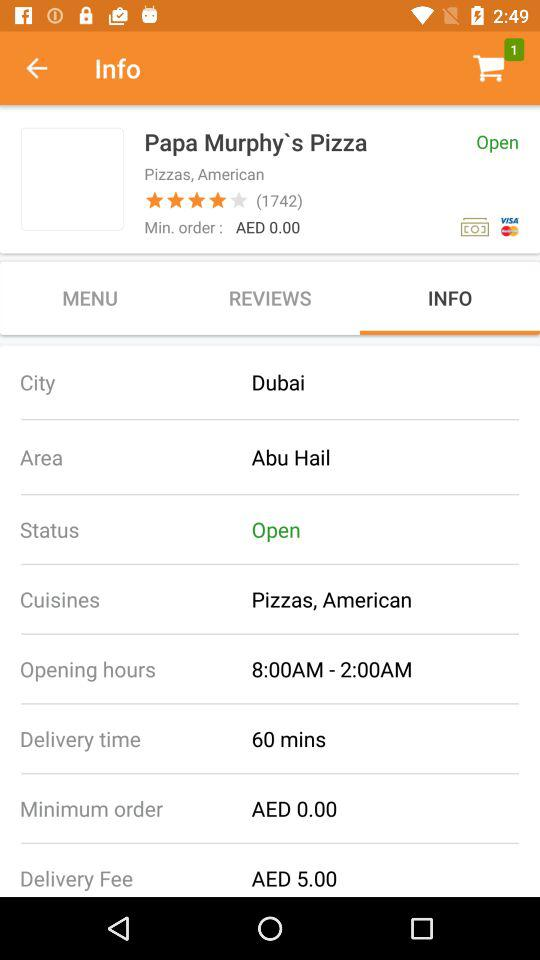What is the cuisine type? The cuisine type is American pizza. 